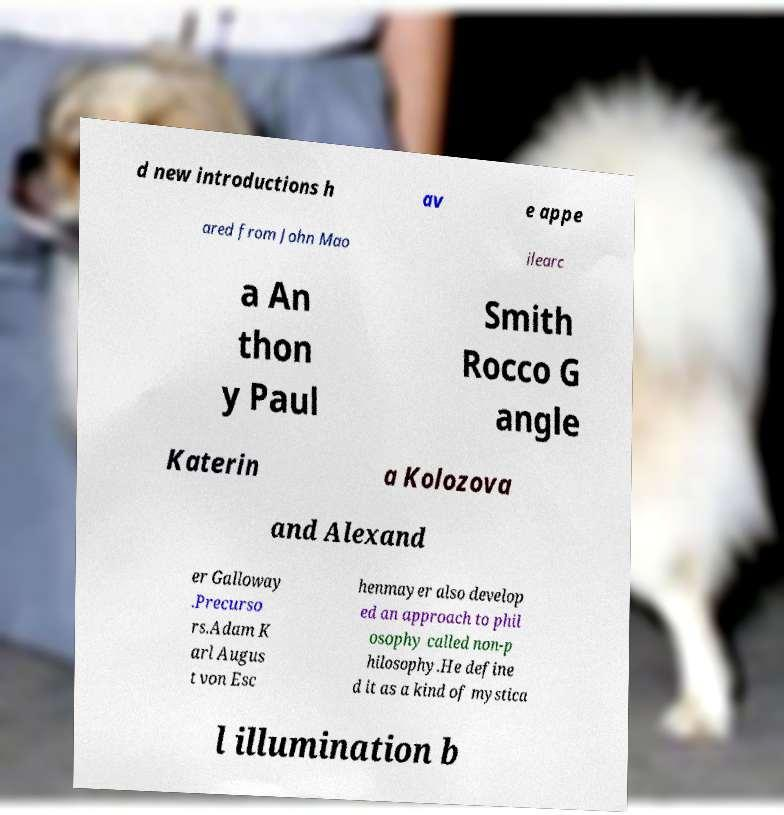Please identify and transcribe the text found in this image. d new introductions h av e appe ared from John Mao ilearc a An thon y Paul Smith Rocco G angle Katerin a Kolozova and Alexand er Galloway .Precurso rs.Adam K arl Augus t von Esc henmayer also develop ed an approach to phil osophy called non-p hilosophy.He define d it as a kind of mystica l illumination b 